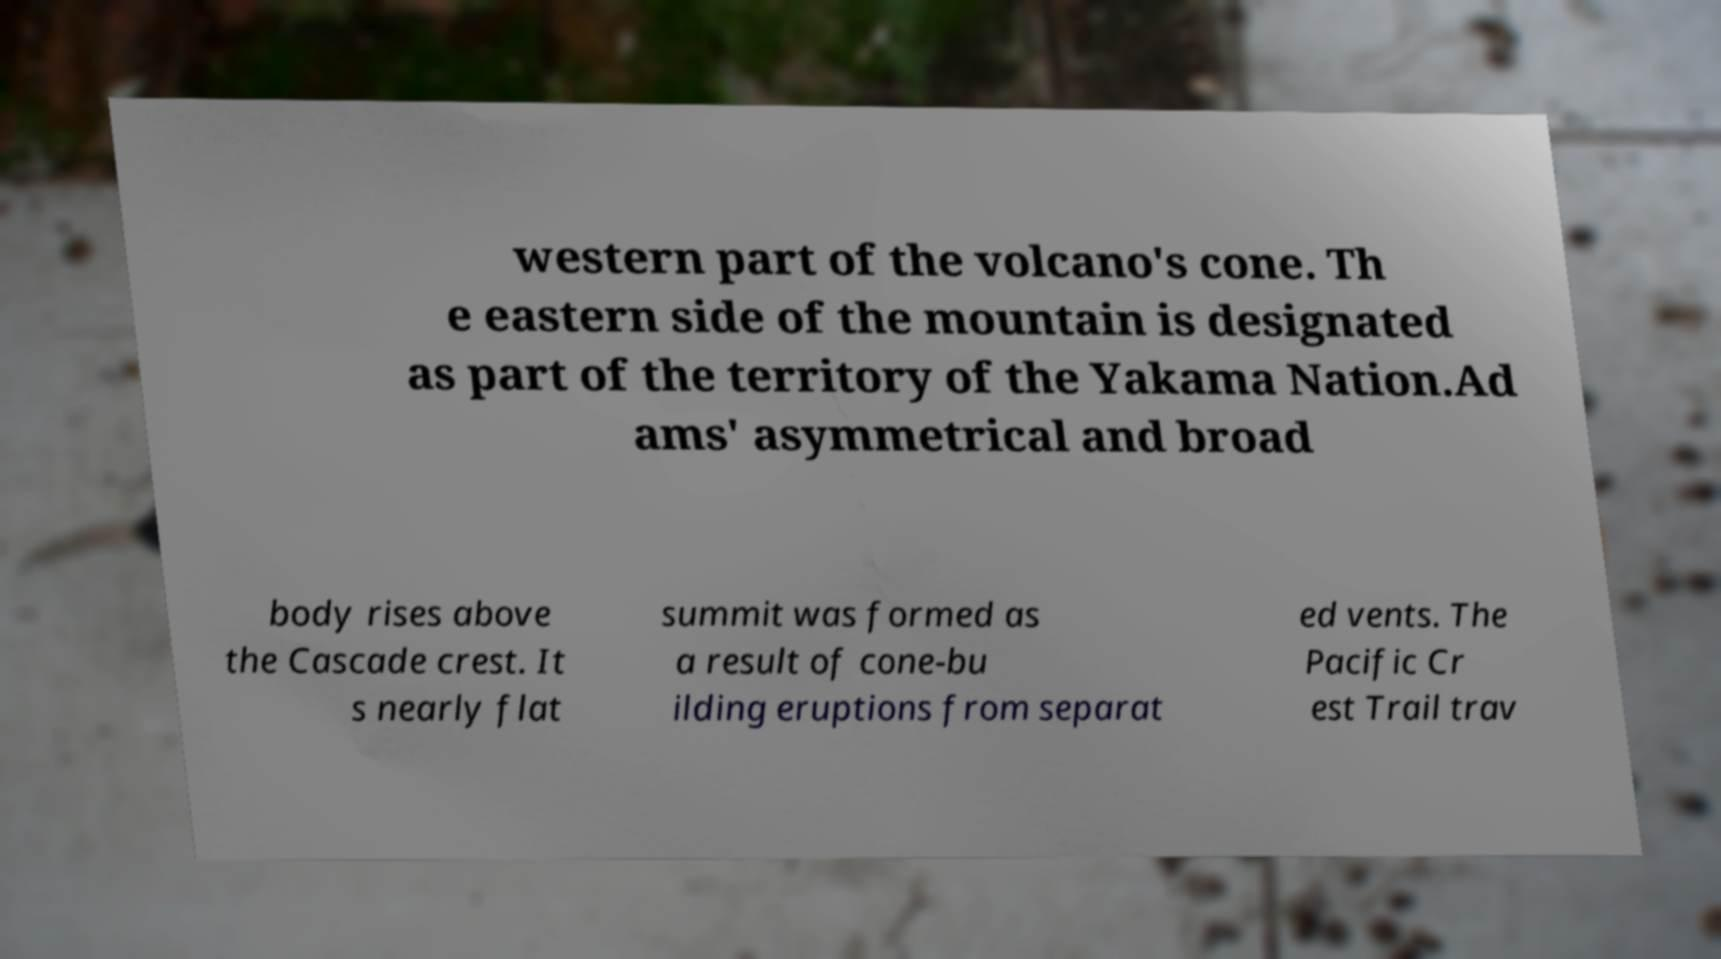For documentation purposes, I need the text within this image transcribed. Could you provide that? western part of the volcano's cone. Th e eastern side of the mountain is designated as part of the territory of the Yakama Nation.Ad ams' asymmetrical and broad body rises above the Cascade crest. It s nearly flat summit was formed as a result of cone-bu ilding eruptions from separat ed vents. The Pacific Cr est Trail trav 